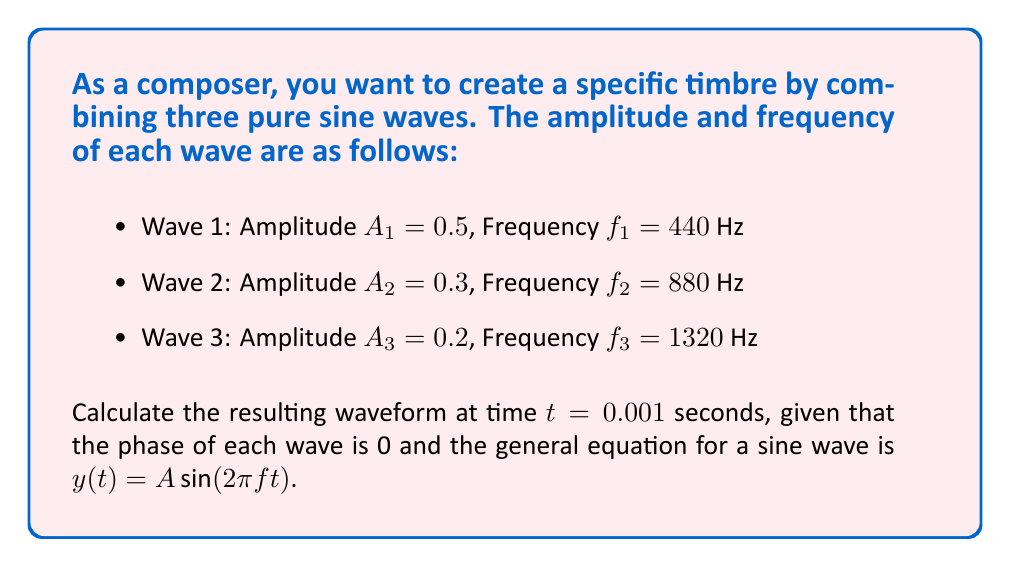Could you help me with this problem? To solve this problem, we need to use the principle of linear combination of waves. Each wave is represented by a sine function, and we'll add them together to get the final waveform.

Let's break it down step by step:

1) The general equation for each wave is:
   $y_i(t) = A_i \sin(2\pi f_i t)$

2) We need to calculate the value of each wave at $t = 0.001$ seconds:

   For Wave 1:
   $y_1(0.001) = 0.5 \sin(2\pi \cdot 440 \cdot 0.001) = 0.5 \sin(2.76460)$

   For Wave 2:
   $y_2(0.001) = 0.3 \sin(2\pi \cdot 880 \cdot 0.001) = 0.3 \sin(5.52920)$

   For Wave 3:
   $y_3(0.001) = 0.2 \sin(2\pi \cdot 1320 \cdot 0.001) = 0.2 \sin(8.29380)$

3) Now, we need to calculate these sine values:
   
   $y_1(0.001) = 0.5 \sin(2.76460) \approx 0.4985$
   $y_2(0.001) = 0.3 \sin(5.52920) \approx -0.2956$
   $y_3(0.001) = 0.2 \sin(8.29380) \approx 0.0285$

4) The final step is to add these values together:

   $y_{total}(0.001) = y_1(0.001) + y_2(0.001) + y_3(0.001)$
   $y_{total}(0.001) = 0.4985 + (-0.2956) + 0.0285$
Answer: $y_{total}(0.001) = 0.2314$ 